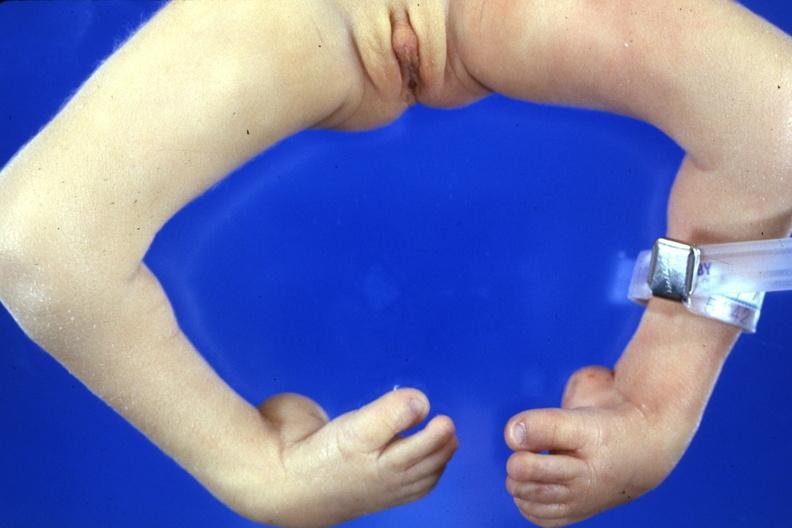does this image show club feet with marked talipes equinovarus?
Answer the question using a single word or phrase. Yes 